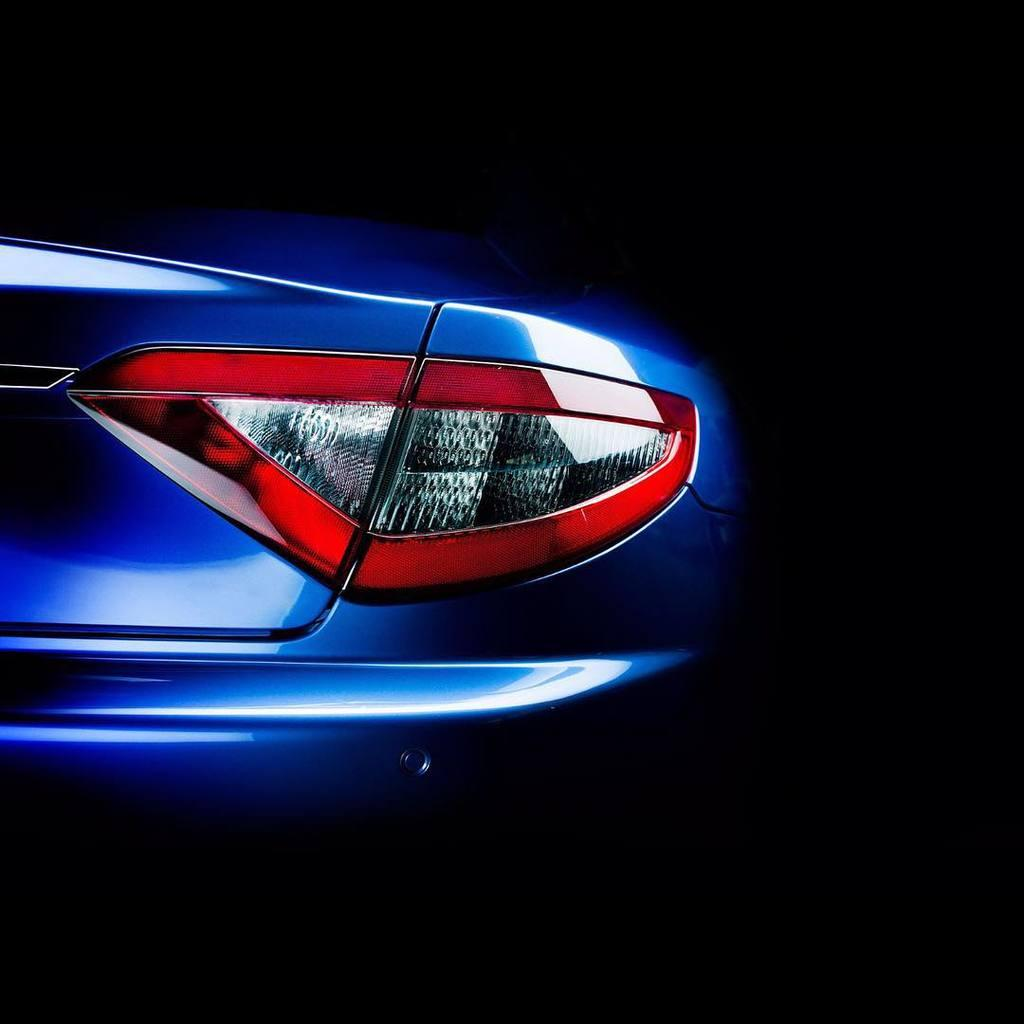What is the main subject of the image? The main subject of the image is a car. Can you describe the color of the car? The car is blue in color. How does the car compare to a bicycle in terms of design? The image does not include a bicycle, so it is not possible to compare the design of the car to a bicycle. 